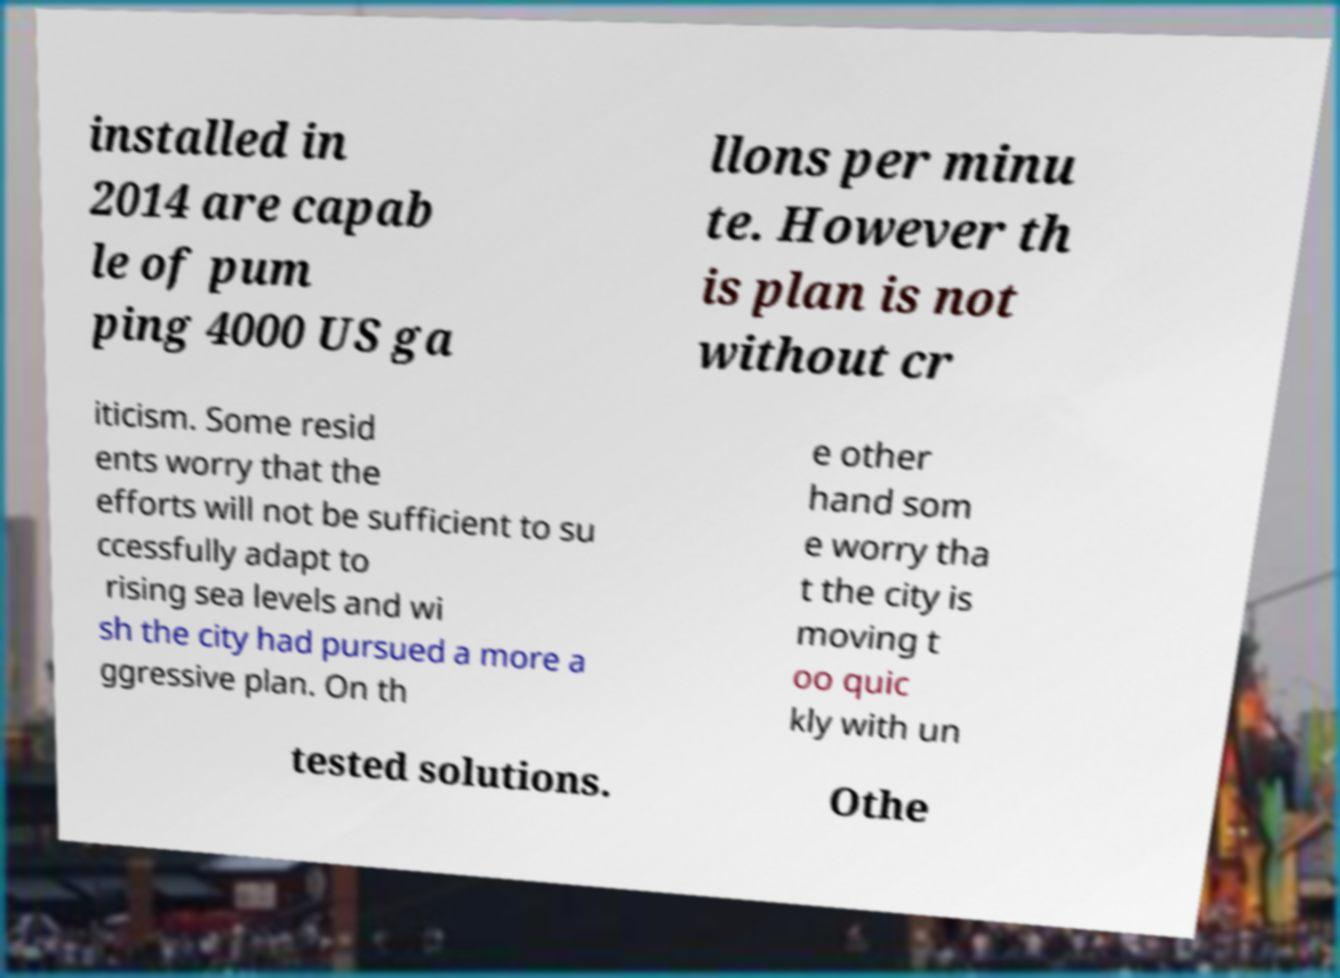There's text embedded in this image that I need extracted. Can you transcribe it verbatim? installed in 2014 are capab le of pum ping 4000 US ga llons per minu te. However th is plan is not without cr iticism. Some resid ents worry that the efforts will not be sufficient to su ccessfully adapt to rising sea levels and wi sh the city had pursued a more a ggressive plan. On th e other hand som e worry tha t the city is moving t oo quic kly with un tested solutions. Othe 